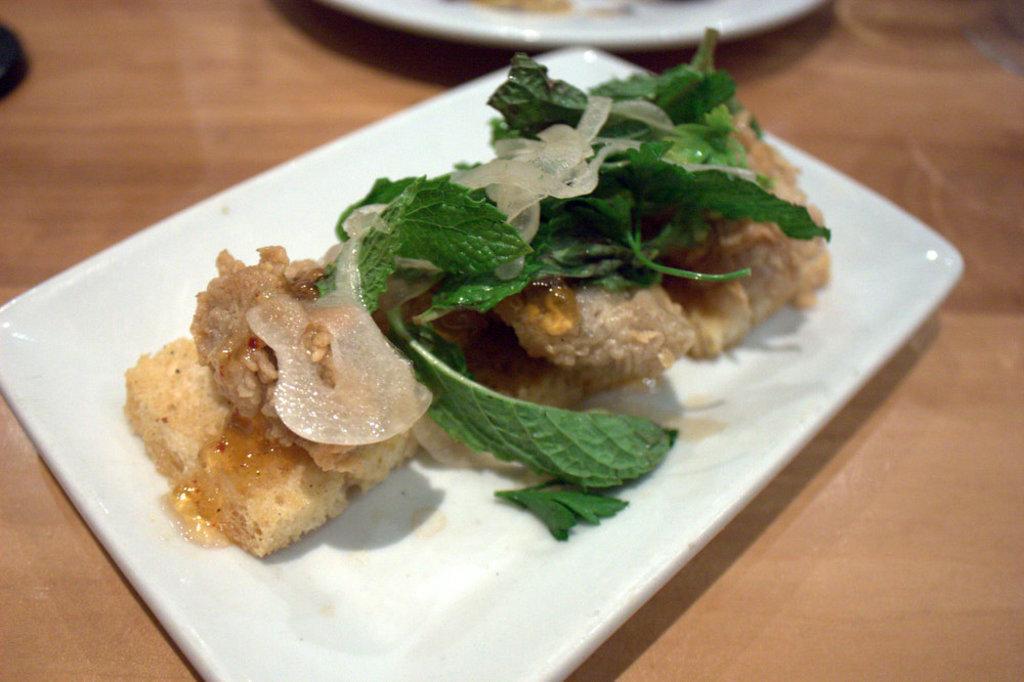Could you give a brief overview of what you see in this image? In this image there is a food item in a plate on the table, beside the plate there is another plate. 